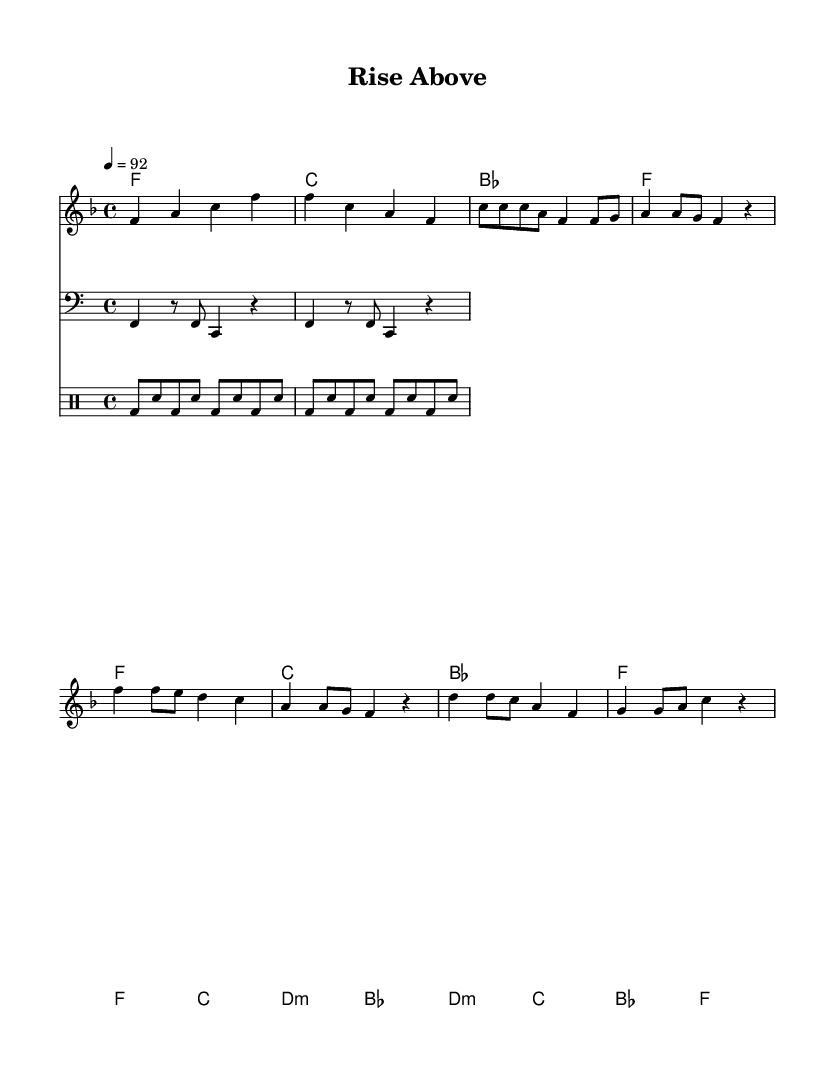What is the key signature of this music? The key signature is F major, which has one flat (B♭). This can be determined by looking at the key signature symbol at the beginning of the staff.
Answer: F major What is the time signature of the music? The time signature is 4/4, which indicates four beats in a measure and is shown as a fraction at the beginning of the score.
Answer: 4/4 What is the tempo marking for this piece? The tempo marking is 92 BPM (beats per minute). This can be found in the tempo text included in the global section of the code.
Answer: 92 How many measures are in the chorus section? The chorus consists of four measures. This can be counted directly from the notation for the chorus section in the sheet music.
Answer: 4 What is the first chord played in the intro? The first chord in the intro is F major. This is identifiable from the harmonies section where the chord is listed as "f" on the first measure of the intro.
Answer: F major What type of musical structure does this piece use? The piece uses verse-chorus-bridge structure, which is common in hip-hop, where the verses tell a story and the chorus emphasizes the main message. This can be determined by the labeling of sections in the sheet music.
Answer: Verse-chorus-bridge What instrument plays the bass part? The bass part is played by a bass instrument, which is indicated by the clef used in the staff. The clef shows that it is intended for bass.
Answer: Bass 